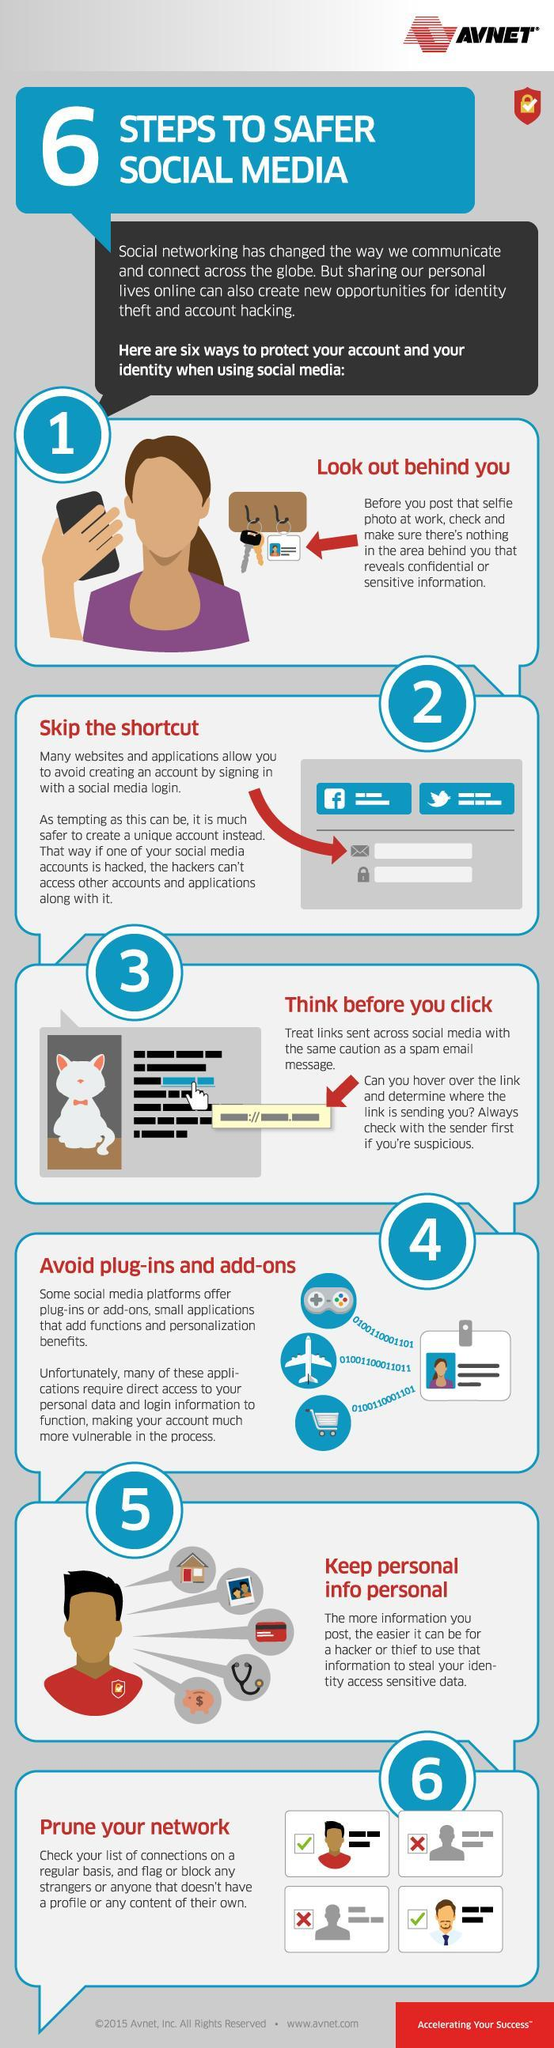What is the color of arrows - red, black or blue?
Answer the question with a short phrase. red In the graphics of 6th step, how many icons of cross are given? 2 How many times the word "social" appeared in this infographic? 7 What is the color in which "6" is written - white, black or red? white What is the color of the aero plane icon - black, blue, or white? white What is the color in which "prune your network" is written - white, black or red? red What is the third step given in this infographic to protect user's identity on social media? think before you click What is the 6th step given to protect user's identity on social media in this infographic? prune your network How many times the number "6" appeared in this infographic? 2 In the heading of 5th step, how many times the word "personal" is written? 2 